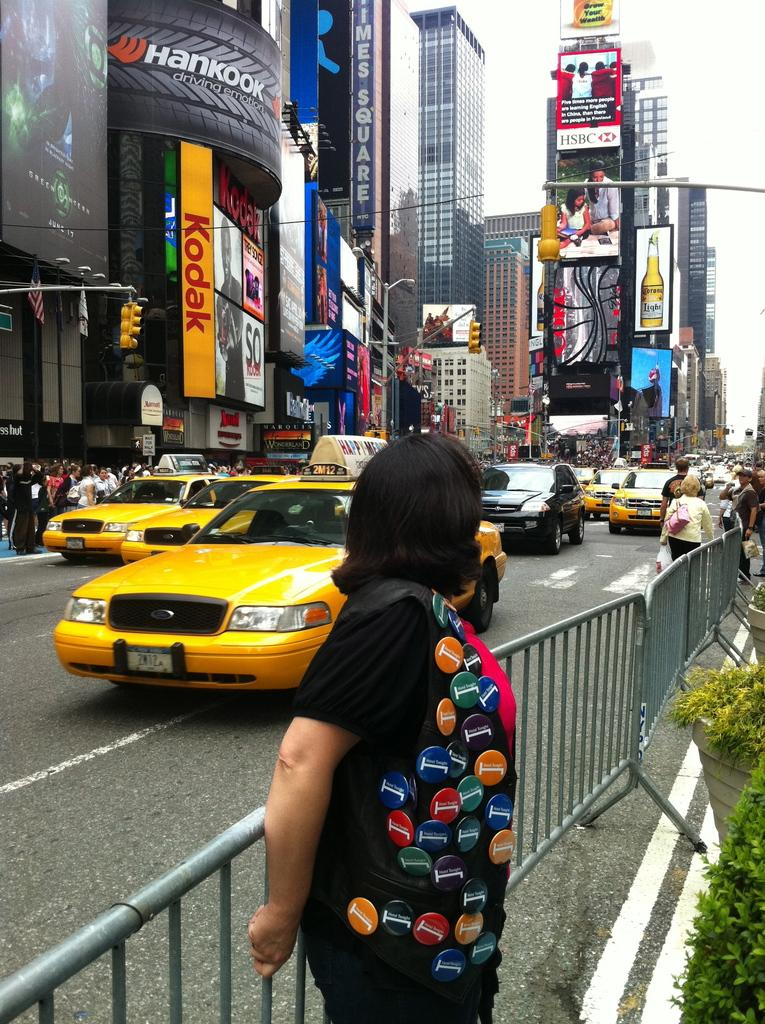Provide a one-sentence caption for the provided image. A woman turns away from the camera as she stands on a street with an ad for kodak in the background. 